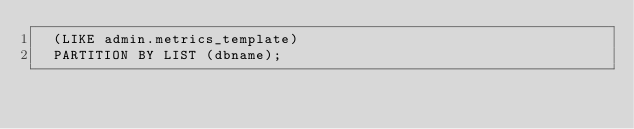Convert code to text. <code><loc_0><loc_0><loc_500><loc_500><_SQL_>  (LIKE admin.metrics_template)
  PARTITION BY LIST (dbname);</code> 